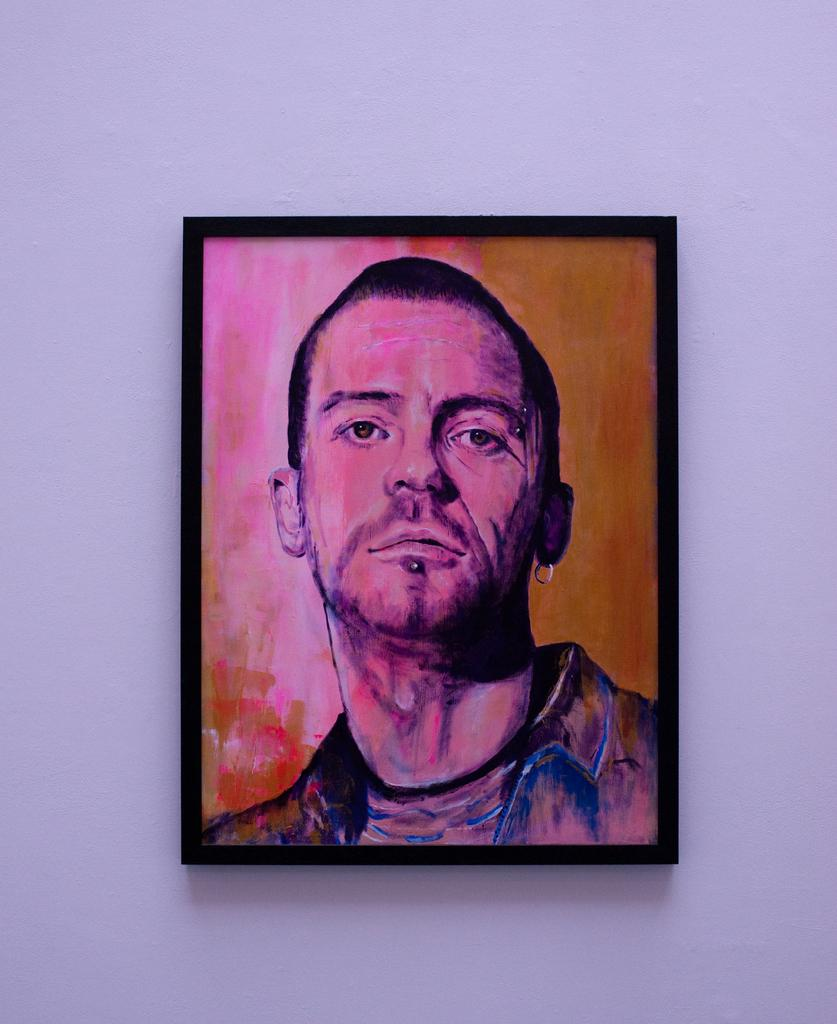What is depicted in the painting that is visible in the image? There is a painting of a person in the image. How is the painting displayed in the image? The painting is on a frame. Where is the frame located in the image? The frame is on a wall. Can you see any friends of the person in the painting in the image? There are no friends visible in the image; the painting only depicts a single person. Is there a boat in the image? No, there is no boat present in the image. 